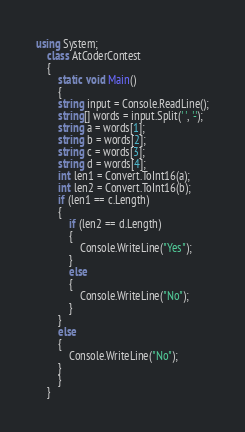<code> <loc_0><loc_0><loc_500><loc_500><_C#_>using System;
    class AtCoderContest
    {
        static void Main()
        {
        string input = Console.ReadLine();
        string[] words = input.Split(' ', '-');
        string a = words[1];
        string b = words[2];
        string c = words[3];
        string d = words[4];
        int len1 = Convert.ToInt16(a);
        int len2 = Convert.ToInt16(b);
        if (len1 == c.Length)
        {
            if (len2 == d.Length)
            {
                Console.WriteLine("Yes");
            }
            else
            {
                Console.WriteLine("No");
            }
        }
        else
        {
            Console.WriteLine("No");
        }
        }
    }

</code> 